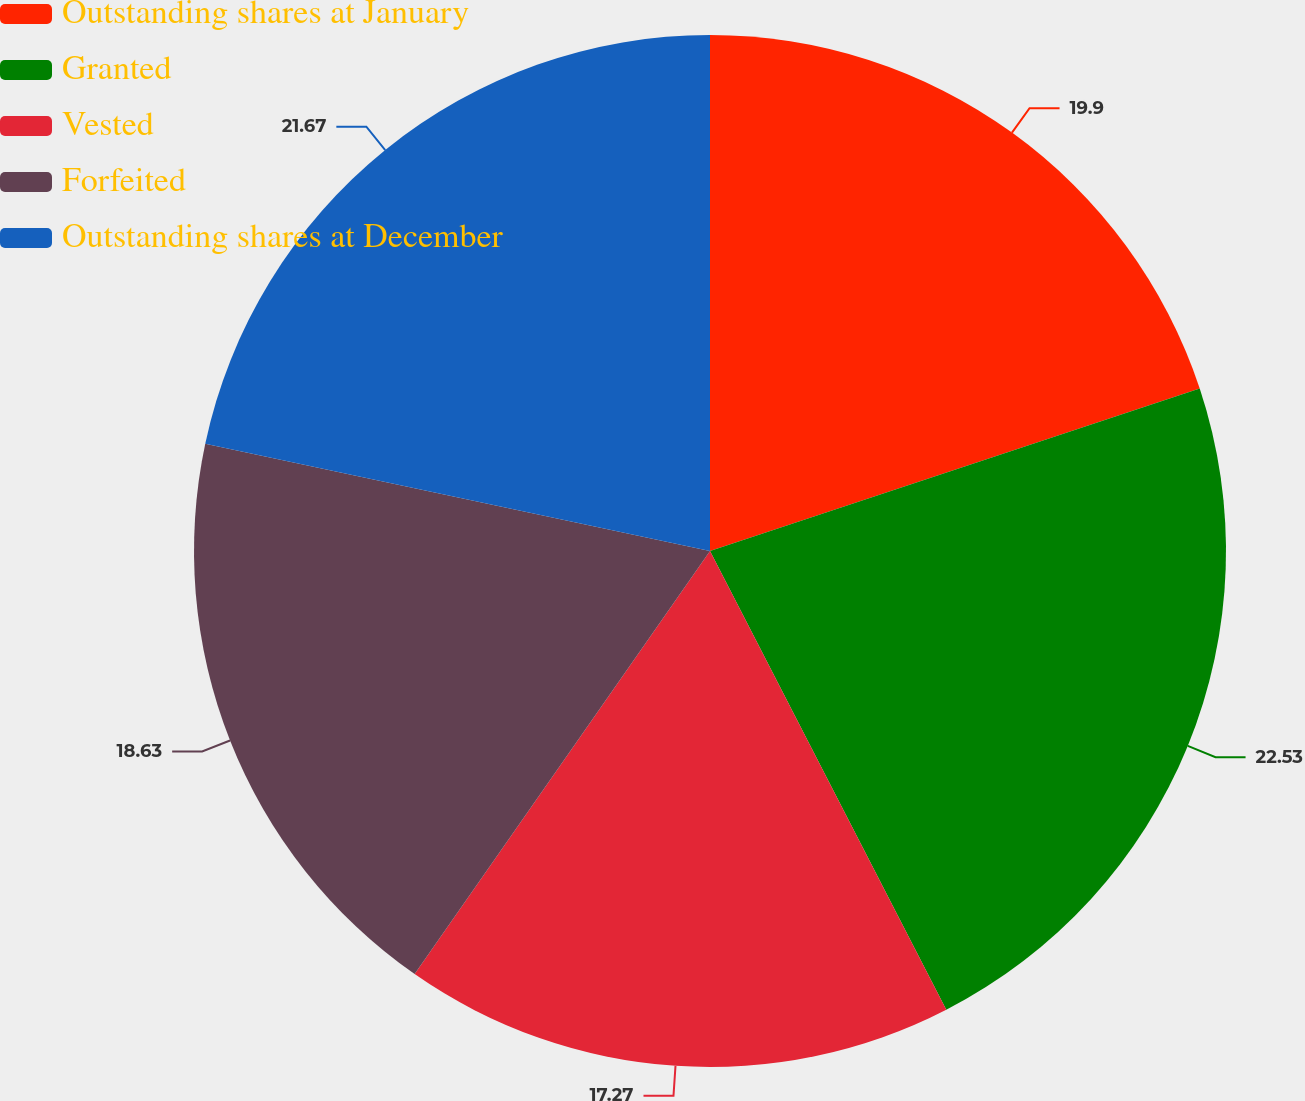Convert chart. <chart><loc_0><loc_0><loc_500><loc_500><pie_chart><fcel>Outstanding shares at January<fcel>Granted<fcel>Vested<fcel>Forfeited<fcel>Outstanding shares at December<nl><fcel>19.9%<fcel>22.53%<fcel>17.27%<fcel>18.63%<fcel>21.67%<nl></chart> 